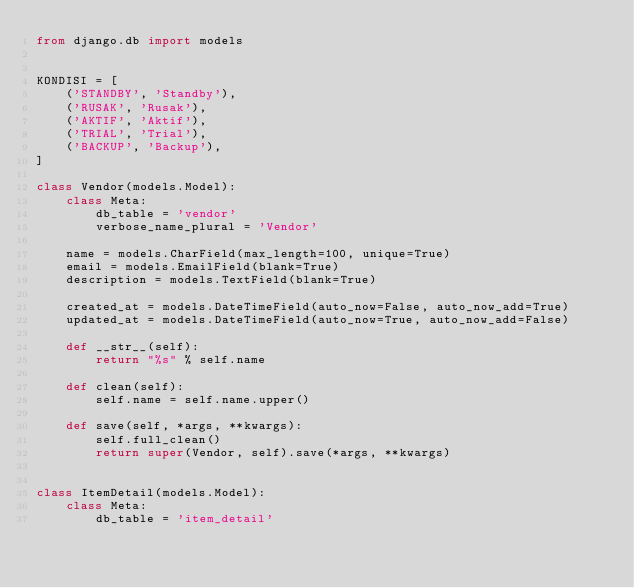<code> <loc_0><loc_0><loc_500><loc_500><_Python_>from django.db import models


KONDISI = [
    ('STANDBY', 'Standby'),
    ('RUSAK', 'Rusak'),
    ('AKTIF', 'Aktif'),
    ('TRIAL', 'Trial'),
    ('BACKUP', 'Backup'),
]

class Vendor(models.Model):
    class Meta:
        db_table = 'vendor'
        verbose_name_plural = 'Vendor'

    name = models.CharField(max_length=100, unique=True)
    email = models.EmailField(blank=True)
    description = models.TextField(blank=True)

    created_at = models.DateTimeField(auto_now=False, auto_now_add=True)
    updated_at = models.DateTimeField(auto_now=True, auto_now_add=False)

    def __str__(self):
        return "%s" % self.name    

    def clean(self):
        self.name = self.name.upper()

    def save(self, *args, **kwargs):
        self.full_clean()
        return super(Vendor, self).save(*args, **kwargs)


class ItemDetail(models.Model):
    class Meta:
        db_table = 'item_detail'</code> 